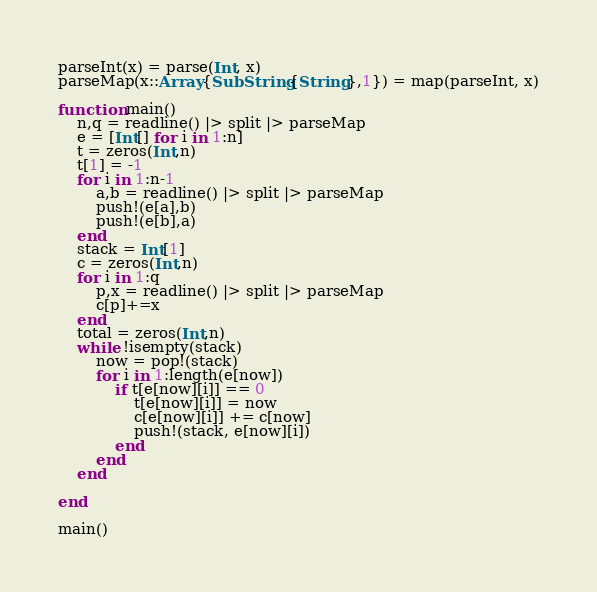<code> <loc_0><loc_0><loc_500><loc_500><_Julia_>parseInt(x) = parse(Int, x)
parseMap(x::Array{SubString{String},1}) = map(parseInt, x)

function main()
	n,q = readline() |> split |> parseMap
	e = [Int[] for i in 1:n]
	t = zeros(Int,n)
	t[1] = -1
	for i in 1:n-1
		a,b = readline() |> split |> parseMap
		push!(e[a],b)
		push!(e[b],a)
	end
	stack = Int[1]
	c = zeros(Int,n)
	for i in 1:q
		p,x = readline() |> split |> parseMap
		c[p]+=x
	end
	total = zeros(Int,n)
	while !isempty(stack)
		now = pop!(stack)
		for i in 1:length(e[now])
			if t[e[now][i]] == 0
				t[e[now][i]] = now
				c[e[now][i]] += c[now]
				push!(stack, e[now][i])
			end
		end
	end
	
end

main()</code> 